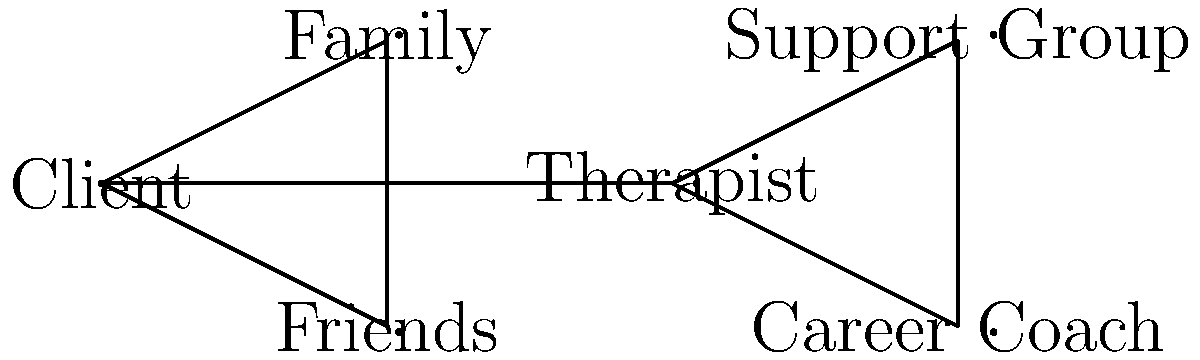In the support network graph for a recovering musician, what is the minimum number of connections that need to be removed to completely isolate the client from their therapist? To solve this problem, we need to analyze the graph and find the minimum cut between the client and the therapist. Let's approach this step-by-step:

1. Identify the nodes: The client is at one end, and the therapist is in the middle of the graph.

2. Find all paths between the client and therapist:
   a. Client -- Therapist (direct connection)
   b. Client -- Family -- Friends -- Therapist
   c. Client -- Friends -- Family -- Therapist

3. To isolate the client from the therapist, we need to cut all these paths.

4. The most efficient way to do this is to remove the following connections:
   a. Client -- Therapist
   b. Client -- Family
   c. Client -- Friends

5. By removing these three connections, we effectively isolate the client from the therapist and the rest of the support network.

6. Note that removing any fewer connections would leave at least one path intact between the client and therapist.

Therefore, the minimum number of connections that need to be removed to completely isolate the client from their therapist is 3.
Answer: 3 